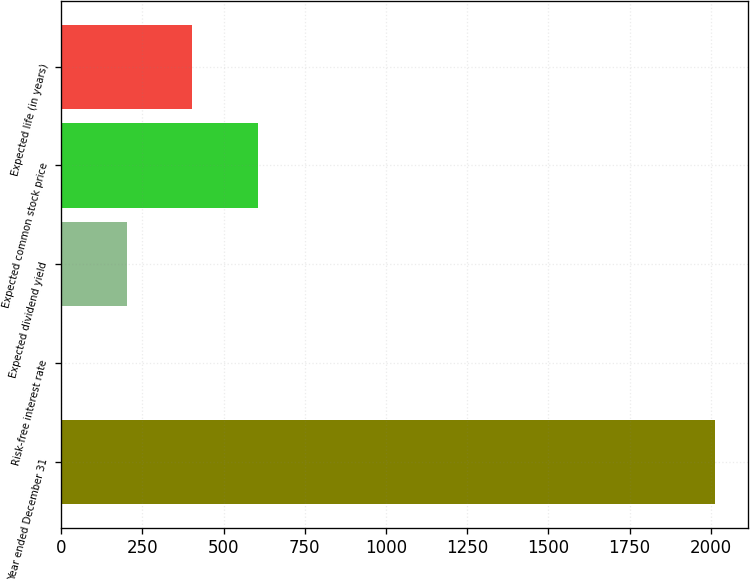Convert chart to OTSL. <chart><loc_0><loc_0><loc_500><loc_500><bar_chart><fcel>Year ended December 31<fcel>Risk-free interest rate<fcel>Expected dividend yield<fcel>Expected common stock price<fcel>Expected life (in years)<nl><fcel>2013<fcel>1.18<fcel>202.36<fcel>604.72<fcel>403.54<nl></chart> 